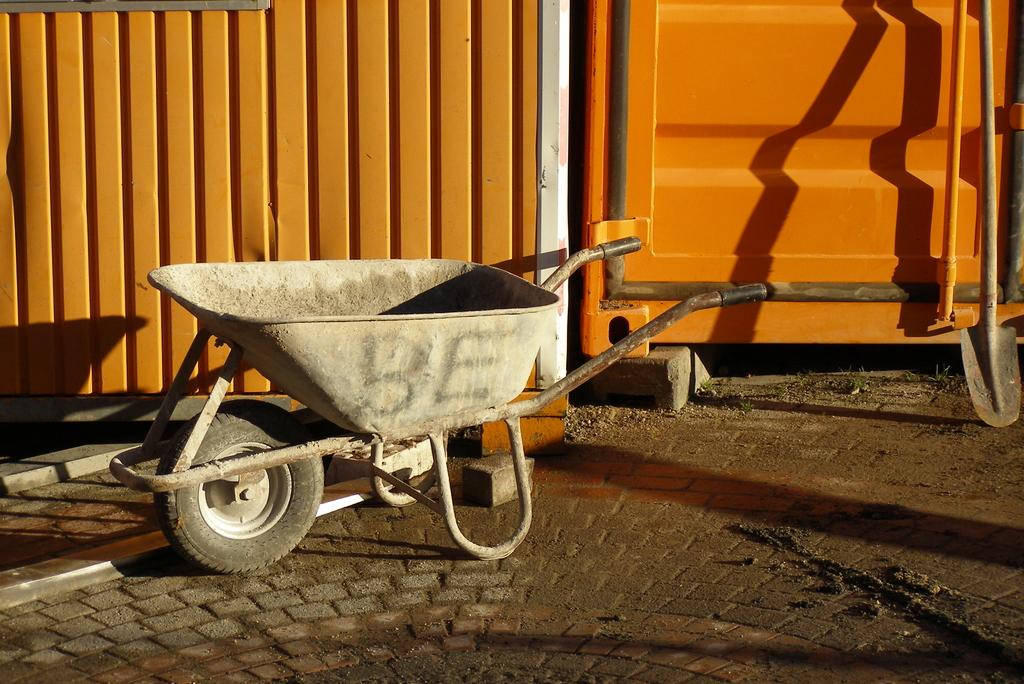What is the main object in the middle of the image? There is a trolley in the middle of the image. What can be seen in the background of the image? There is an iron gate in the background of the image. What is the color of the iron gate? The iron gate is red in color. What type of machinery is located at the right side of the image? There is a digger at the right side of the image. Can you see any clouds in the image? There is no mention of clouds in the provided facts, and therefore we cannot determine if clouds are present in the image. 